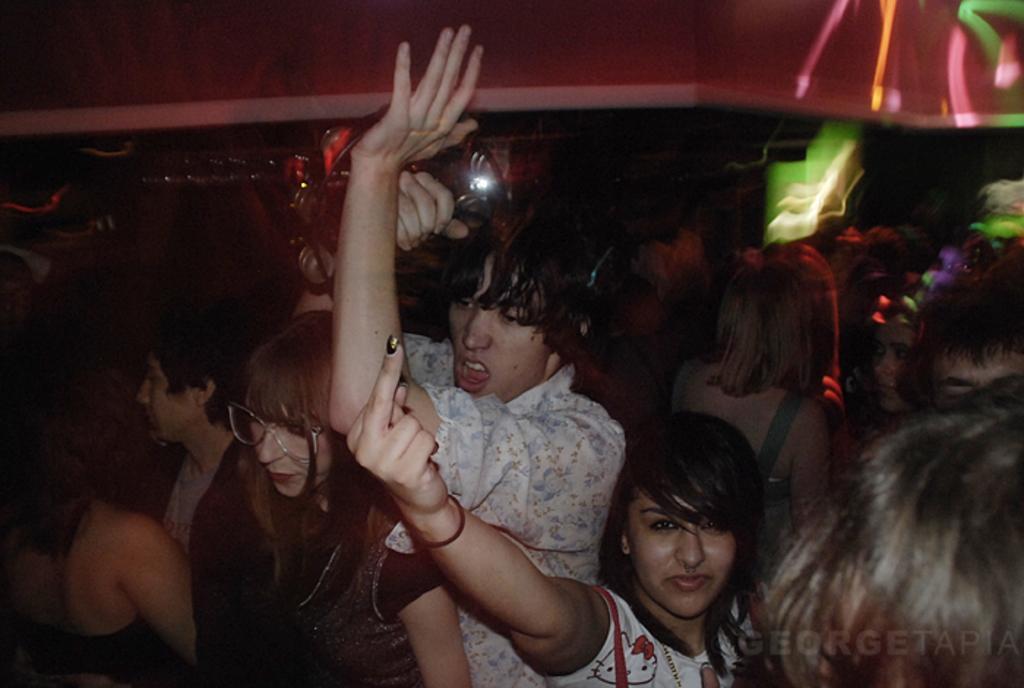Could you give a brief overview of what you see in this image? In this image I can see number of people are standing. On the top right side of this image I can see few lights and on the bottom right side I can see a watermark. 